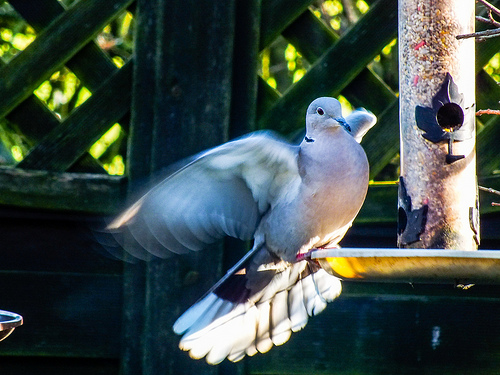<image>
Is the bird to the right of the bird feeder? No. The bird is not to the right of the bird feeder. The horizontal positioning shows a different relationship. 